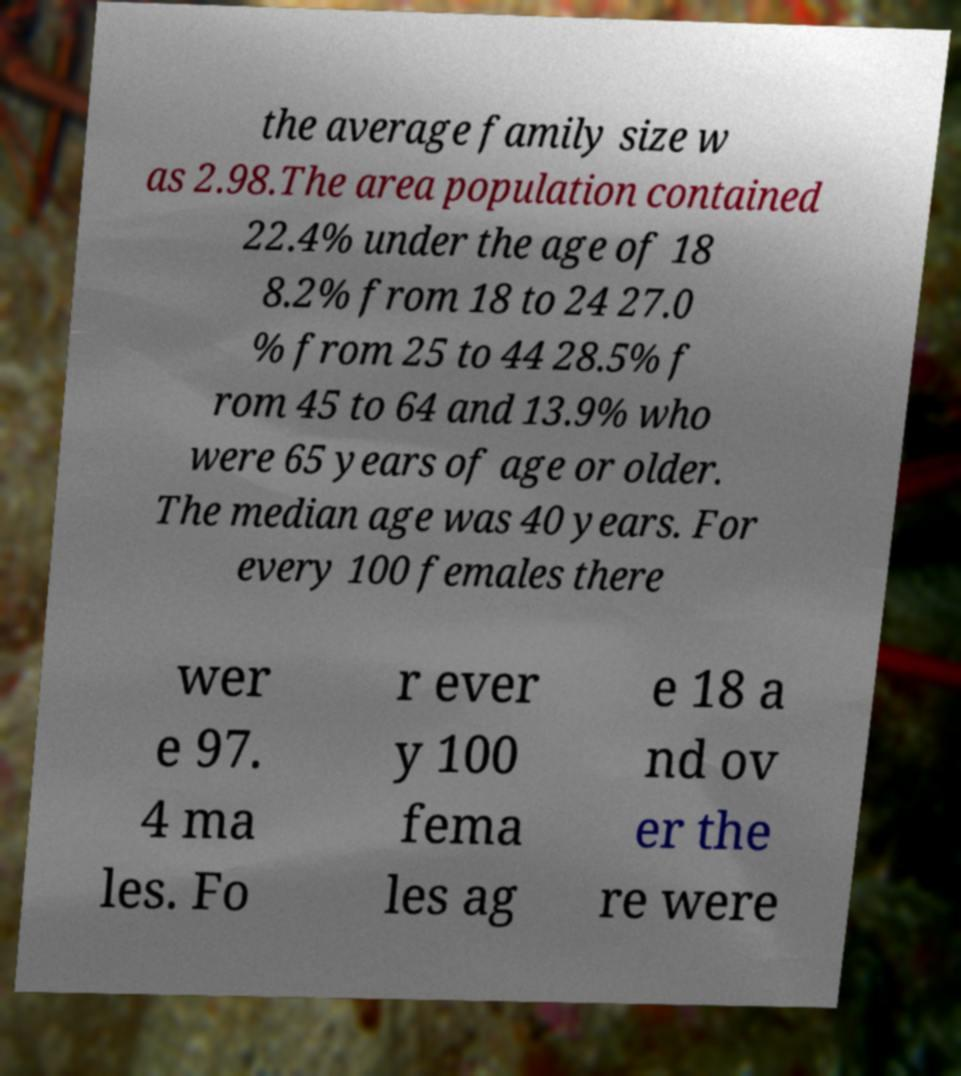Please identify and transcribe the text found in this image. the average family size w as 2.98.The area population contained 22.4% under the age of 18 8.2% from 18 to 24 27.0 % from 25 to 44 28.5% f rom 45 to 64 and 13.9% who were 65 years of age or older. The median age was 40 years. For every 100 females there wer e 97. 4 ma les. Fo r ever y 100 fema les ag e 18 a nd ov er the re were 